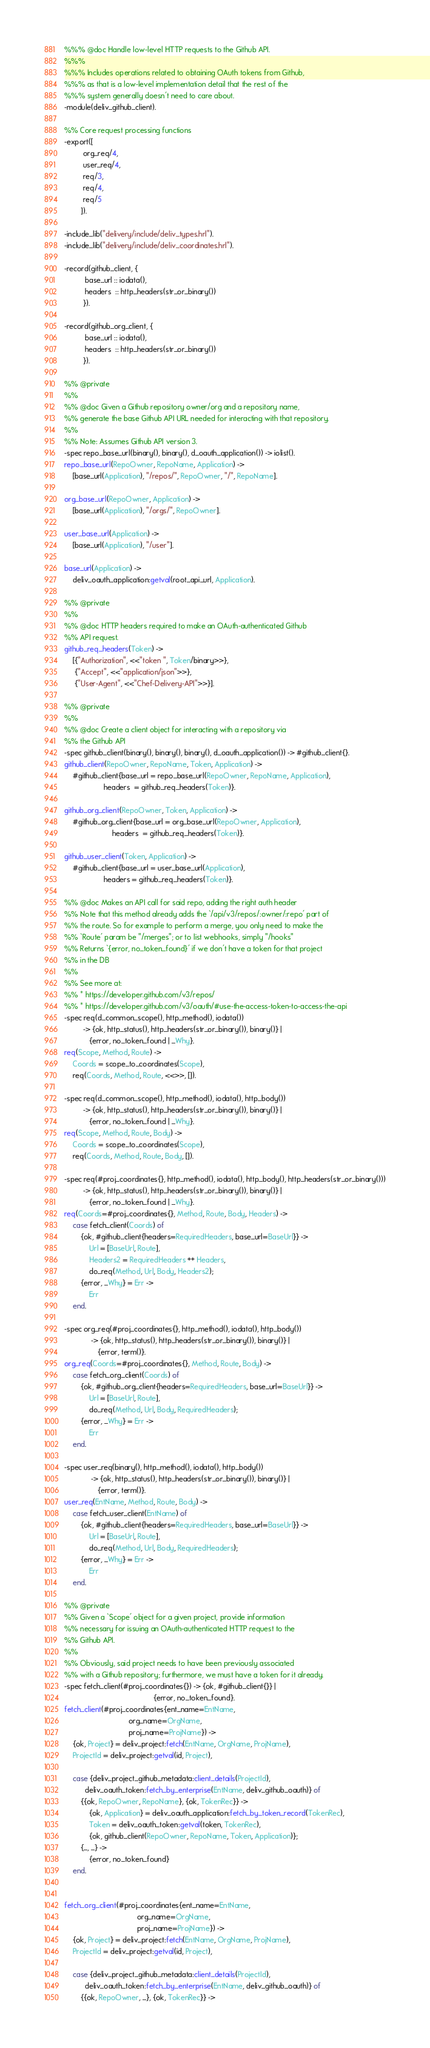Convert code to text. <code><loc_0><loc_0><loc_500><loc_500><_Erlang_>%%% @doc Handle low-level HTTP requests to the Github API.
%%%
%%% Includes operations related to obtaining OAuth tokens from Github,
%%% as that is a low-level implementation detail that the rest of the
%%% system generally doesn't need to care about.
-module(deliv_github_client).

%% Core request processing functions
-export([
         org_req/4,
         user_req/4,
         req/3,
         req/4,
         req/5
        ]).

-include_lib("delivery/include/deliv_types.hrl").
-include_lib("delivery/include/deliv_coordinates.hrl").

-record(github_client, {
          base_url :: iodata(),
          headers  :: http_headers(str_or_binary())
         }).

-record(github_org_client, {
          base_url :: iodata(),
          headers  :: http_headers(str_or_binary())
         }).

%% @private
%%
%% @doc Given a Github repository owner/org and a repository name,
%% generate the base Github API URL needed for interacting with that repository.
%%
%% Note: Assumes Github API version 3.
-spec repo_base_url(binary(), binary(), d_oauth_application()) -> iolist().
repo_base_url(RepoOwner, RepoName, Application) ->
    [base_url(Application), "/repos/", RepoOwner, "/", RepoName].

org_base_url(RepoOwner, Application) ->
    [base_url(Application), "/orgs/", RepoOwner].

user_base_url(Application) ->
    [base_url(Application), "/user"].

base_url(Application) ->
    deliv_oauth_application:getval(root_api_url, Application).

%% @private
%%
%% @doc HTTP headers required to make an OAuth-authenticated Github
%% API request.
github_req_headers(Token) ->
    [{"Authorization", <<"token ", Token/binary>>},
     {"Accept", <<"application/json">>},
     {"User-Agent", <<"Chef-Delivery-API">>}].

%% @private
%%
%% @doc Create a client object for interacting with a repository via
%% the Github API
-spec github_client(binary(), binary(), binary(), d_oauth_application()) -> #github_client{}.
github_client(RepoOwner, RepoName, Token, Application) ->
    #github_client{base_url = repo_base_url(RepoOwner, RepoName, Application),
                   headers  = github_req_headers(Token)}.

github_org_client(RepoOwner, Token, Application) ->
    #github_org_client{base_url = org_base_url(RepoOwner, Application),
                       headers  = github_req_headers(Token)}.

github_user_client(Token, Application) ->
    #github_client{base_url = user_base_url(Application),
                   headers = github_req_headers(Token)}.

%% @doc Makes an API call for said repo, adding the right auth header
%% Note that this method already adds the `/api/v3/repos/:owner/:repo' part of
%% the route. So for example to perform a merge, you only need to make the
%% `Route' param be "/merges"; or to list webhooks, simply "/hooks"
%% Returns `{error, no_token_found}' if we don't have a token for that project
%% in the DB
%%
%% See more at:
%% * https://developer.github.com/v3/repos/
%% * https://developer.github.com/v3/oauth/#use-the-access-token-to-access-the-api
-spec req(d_common_scope(), http_method(), iodata())
         -> {ok, http_status(), http_headers(str_or_binary()), binary()} |
            {error, no_token_found | _Why}.
req(Scope, Method, Route) ->
    Coords = scope_to_coordinates(Scope),
    req(Coords, Method, Route, <<>>, []).

-spec req(d_common_scope(), http_method(), iodata(), http_body())
         -> {ok, http_status(), http_headers(str_or_binary()), binary()} |
            {error, no_token_found | _Why}.
req(Scope, Method, Route, Body) ->
    Coords = scope_to_coordinates(Scope),
    req(Coords, Method, Route, Body, []).

-spec req(#proj_coordinates{}, http_method(), iodata(), http_body(), http_headers(str_or_binary()))
         -> {ok, http_status(), http_headers(str_or_binary()), binary()} |
            {error, no_token_found | _Why}.
req(Coords=#proj_coordinates{}, Method, Route, Body, Headers) ->
    case fetch_client(Coords) of
        {ok, #github_client{headers=RequiredHeaders, base_url=BaseUrl}} ->
            Url = [BaseUrl, Route],
            Headers2 = RequiredHeaders ++ Headers,
            do_req(Method, Url, Body, Headers2);
        {error, _Why} = Err ->
            Err
    end.

-spec org_req(#proj_coordinates{}, http_method(), iodata(), http_body())
             -> {ok, http_status(), http_headers(str_or_binary()), binary()} |
                {error, term()}.
org_req(Coords=#proj_coordinates{}, Method, Route, Body) ->
    case fetch_org_client(Coords) of
        {ok, #github_org_client{headers=RequiredHeaders, base_url=BaseUrl}} ->
            Url = [BaseUrl, Route],
            do_req(Method, Url, Body, RequiredHeaders);
        {error, _Why} = Err ->
            Err
    end.

-spec user_req(binary(), http_method(), iodata(), http_body())
             -> {ok, http_status(), http_headers(str_or_binary()), binary()} |
                {error, term()}.
user_req(EntName, Method, Route, Body) ->
    case fetch_user_client(EntName) of
        {ok, #github_client{headers=RequiredHeaders, base_url=BaseUrl}} ->
            Url = [BaseUrl, Route],
            do_req(Method, Url, Body, RequiredHeaders);
        {error, _Why} = Err ->
            Err
    end.

%% @private
%% Given a `Scope' object for a given project, provide information
%% necessary for issuing an OAuth-authenticated HTTP request to the
%% Github API.
%%
%% Obviously, said project needs to have been previously associated
%% with a Github repository; furthermore, we must have a token for it already.
-spec fetch_client(#proj_coordinates{}) -> {ok, #github_client{}} |
                                           {error, no_token_found}.
fetch_client(#proj_coordinates{ent_name=EntName,
                               org_name=OrgName,
                               proj_name=ProjName}) ->
    {ok, Project} = deliv_project:fetch(EntName, OrgName, ProjName),
    ProjectId = deliv_project:getval(id, Project),

    case {deliv_project_github_metadata:client_details(ProjectId),
          deliv_oauth_token:fetch_by_enterprise(EntName, deliv_github_oauth)} of
        {{ok, RepoOwner, RepoName}, {ok, TokenRec}} ->
            {ok, Application} = deliv_oauth_application:fetch_by_token_record(TokenRec),
            Token = deliv_oauth_token:getval(token, TokenRec),
            {ok, github_client(RepoOwner, RepoName, Token, Application)};
        {_, _} ->
            {error, no_token_found}
    end.


fetch_org_client(#proj_coordinates{ent_name=EntName,
                                   org_name=OrgName,
                                   proj_name=ProjName}) ->
    {ok, Project} = deliv_project:fetch(EntName, OrgName, ProjName),
    ProjectId = deliv_project:getval(id, Project),

    case {deliv_project_github_metadata:client_details(ProjectId),
          deliv_oauth_token:fetch_by_enterprise(EntName, deliv_github_oauth)} of
        {{ok, RepoOwner, _}, {ok, TokenRec}} -></code> 